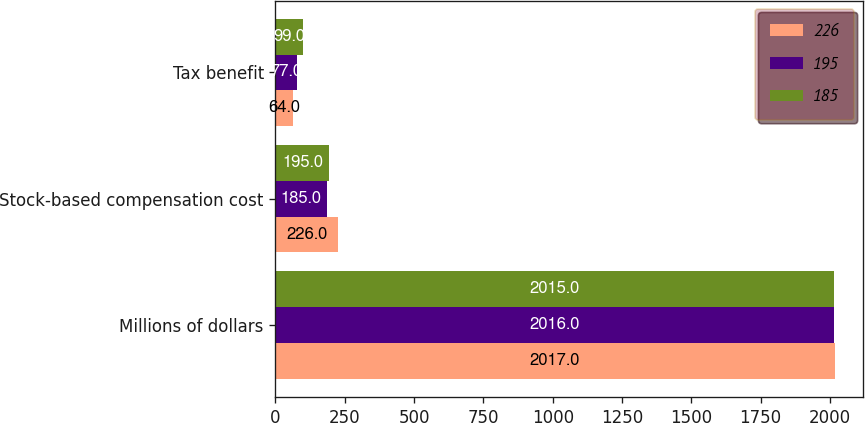<chart> <loc_0><loc_0><loc_500><loc_500><stacked_bar_chart><ecel><fcel>Millions of dollars<fcel>Stock-based compensation cost<fcel>Tax benefit<nl><fcel>226<fcel>2017<fcel>226<fcel>64<nl><fcel>195<fcel>2016<fcel>185<fcel>77<nl><fcel>185<fcel>2015<fcel>195<fcel>99<nl></chart> 